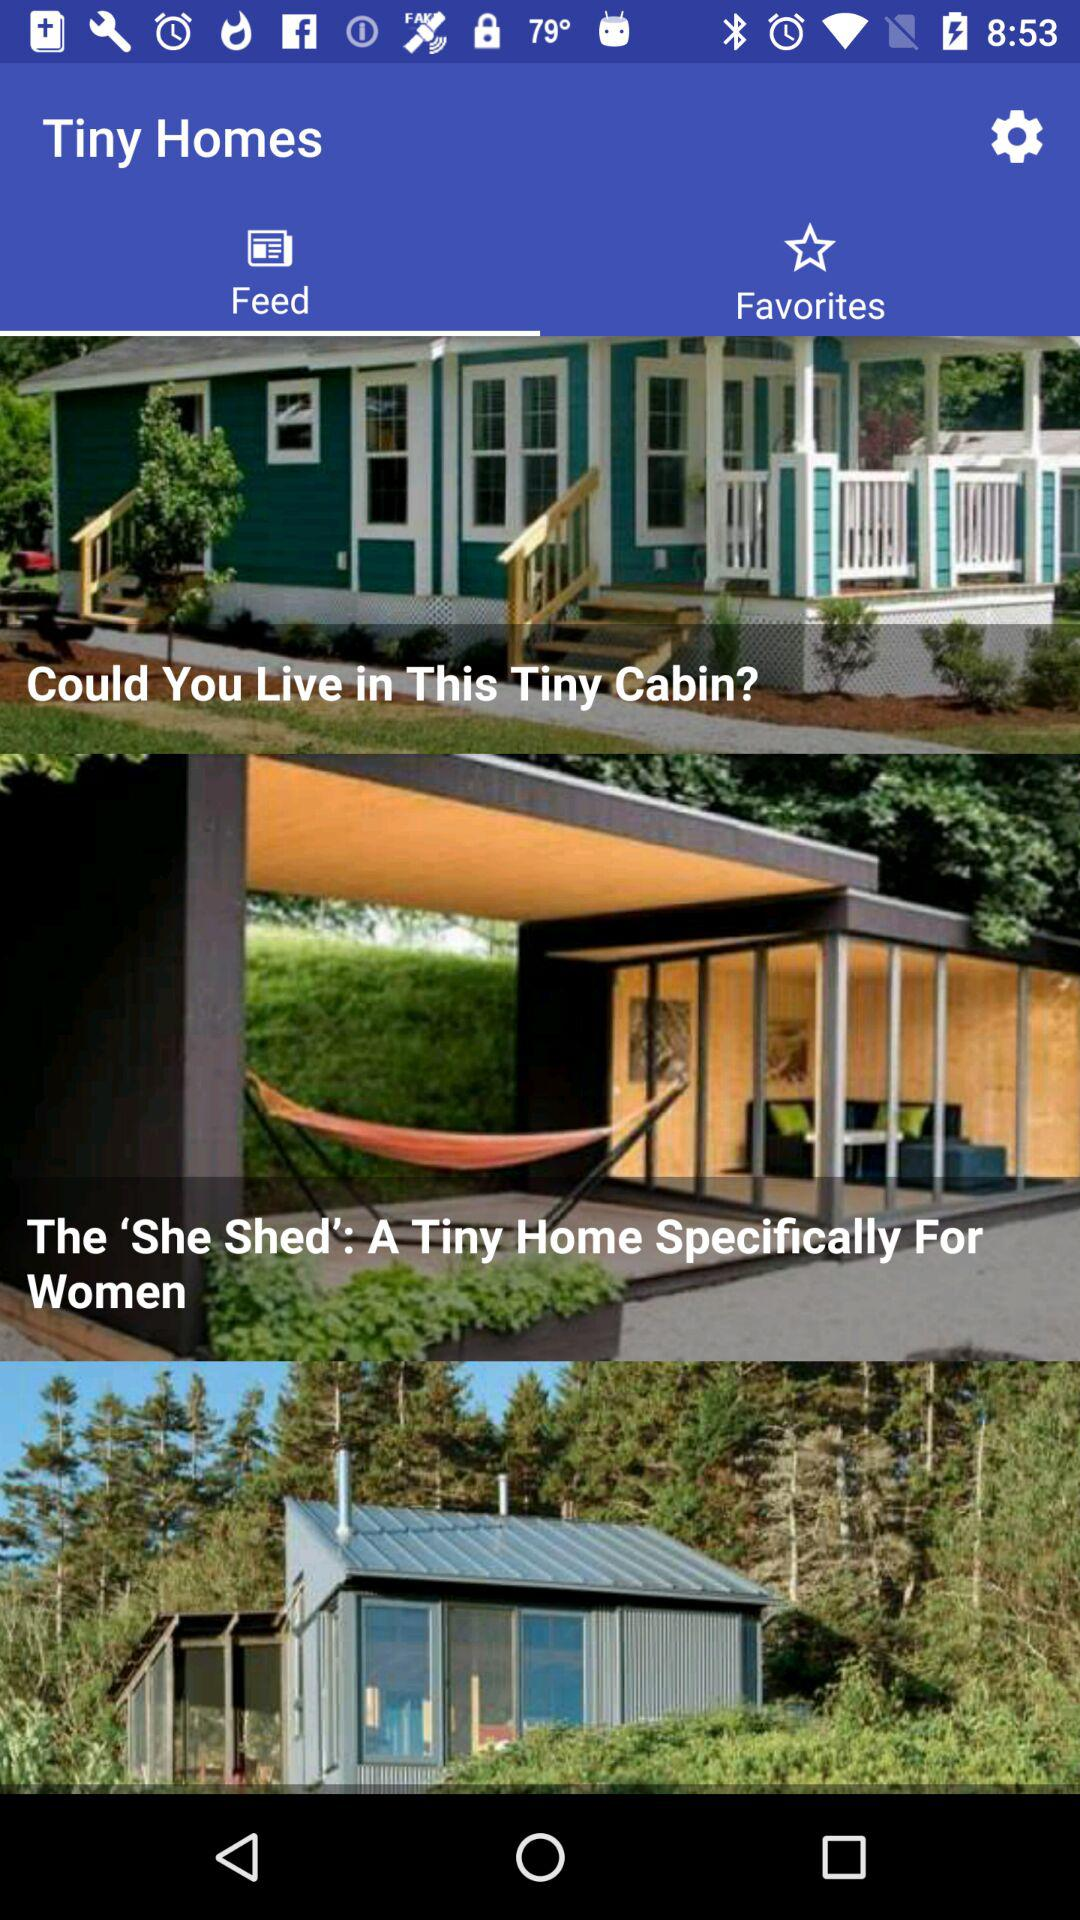Which tab is selected? The selected tab is "Feed". 